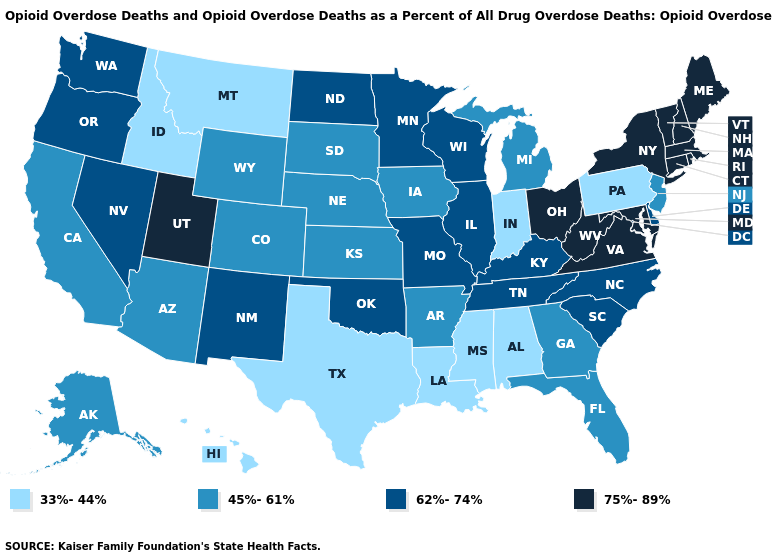Among the states that border Missouri , which have the highest value?
Short answer required. Illinois, Kentucky, Oklahoma, Tennessee. Name the states that have a value in the range 45%-61%?
Keep it brief. Alaska, Arizona, Arkansas, California, Colorado, Florida, Georgia, Iowa, Kansas, Michigan, Nebraska, New Jersey, South Dakota, Wyoming. Does Florida have the same value as Mississippi?
Be succinct. No. What is the value of Iowa?
Be succinct. 45%-61%. What is the value of West Virginia?
Concise answer only. 75%-89%. What is the value of Idaho?
Short answer required. 33%-44%. Does Texas have a lower value than Montana?
Concise answer only. No. Does the first symbol in the legend represent the smallest category?
Short answer required. Yes. What is the lowest value in states that border Illinois?
Give a very brief answer. 33%-44%. What is the highest value in the South ?
Quick response, please. 75%-89%. Which states have the lowest value in the USA?
Write a very short answer. Alabama, Hawaii, Idaho, Indiana, Louisiana, Mississippi, Montana, Pennsylvania, Texas. Name the states that have a value in the range 75%-89%?
Answer briefly. Connecticut, Maine, Maryland, Massachusetts, New Hampshire, New York, Ohio, Rhode Island, Utah, Vermont, Virginia, West Virginia. What is the value of Nevada?
Quick response, please. 62%-74%. What is the value of Kentucky?
Write a very short answer. 62%-74%. Which states have the lowest value in the USA?
Write a very short answer. Alabama, Hawaii, Idaho, Indiana, Louisiana, Mississippi, Montana, Pennsylvania, Texas. 